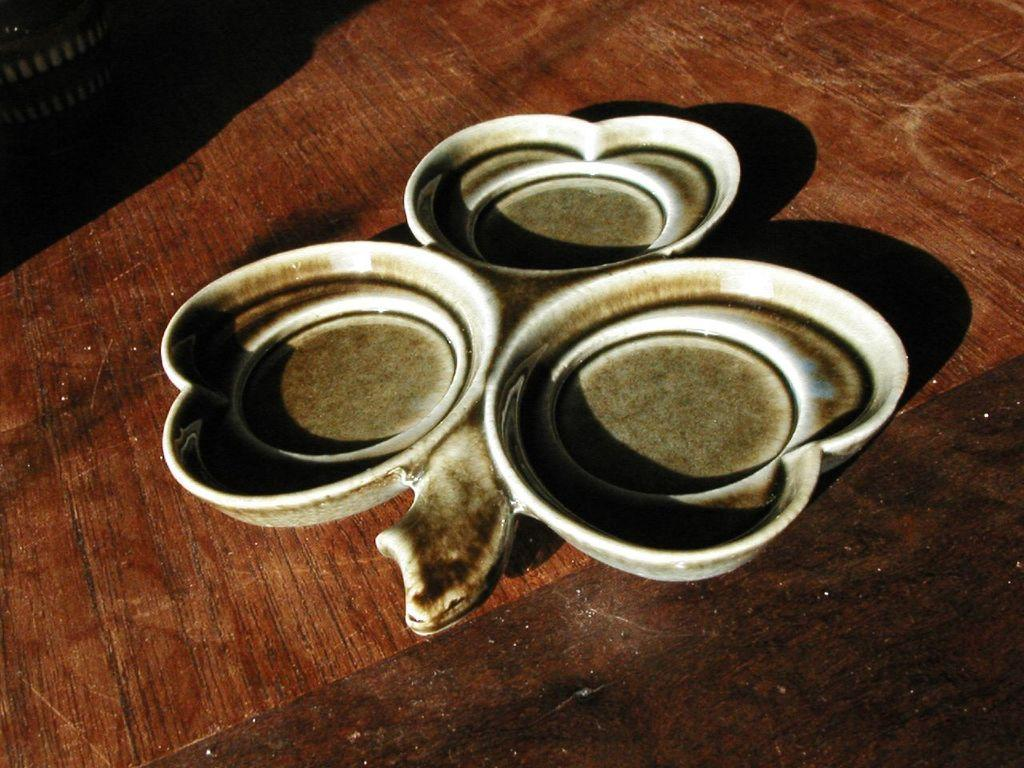What shape is the plate in the image? The plate in the image is leaf-shaped. Where is the plate located? The plate is on a wooden path. Can you describe anything visible in the background of the image? There is an item visible in the background of the image, but its specific details are not mentioned in the provided facts. What type of cannon is present on the leaf-shaped plate in the image? There is no cannon present on the leaf-shaped plate in the image. 